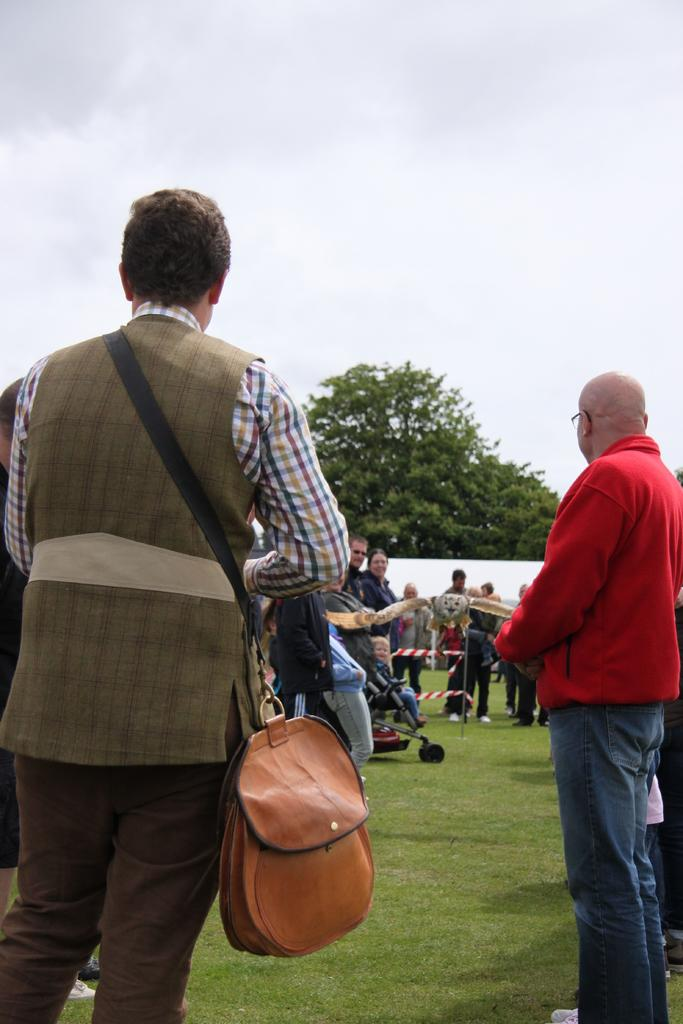What is the main subject of the image? The main subject of the image is a group of people. What are the people in the image doing? The people are standing. Can you describe the person on the left side of the image? The person on the left side is wearing a bag. What can be seen in the background of the image? Trees and the sky are visible in the background of the image. What type of property is being fought over in the image? There is no indication of a fight or property in the image; it features a group of people standing with trees and the sky visible in the background. 